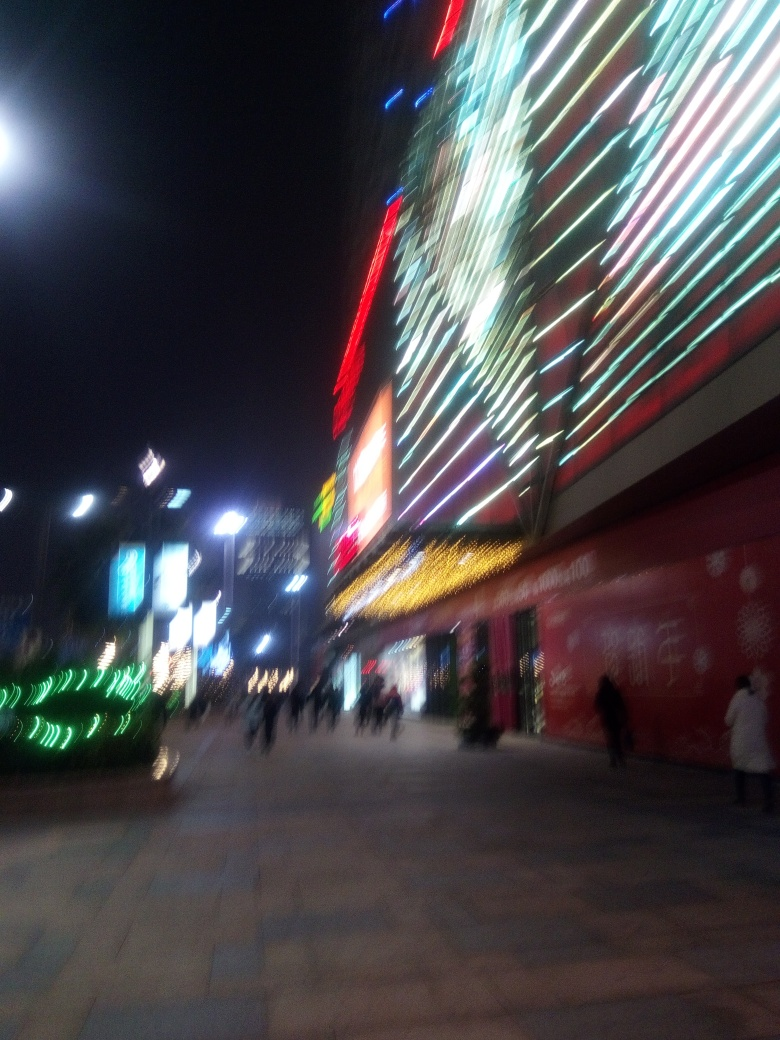Can you describe the atmosphere or mood of the location shown in this image? The atmosphere appears dynamic and bustling. The glimmering lights, illuminated advertisements, and visible people walking suggest that this location is a busy urban area, likely a shopping district or commercial street. The motion blur adds a sense of rapid movement and energy to the scene. 